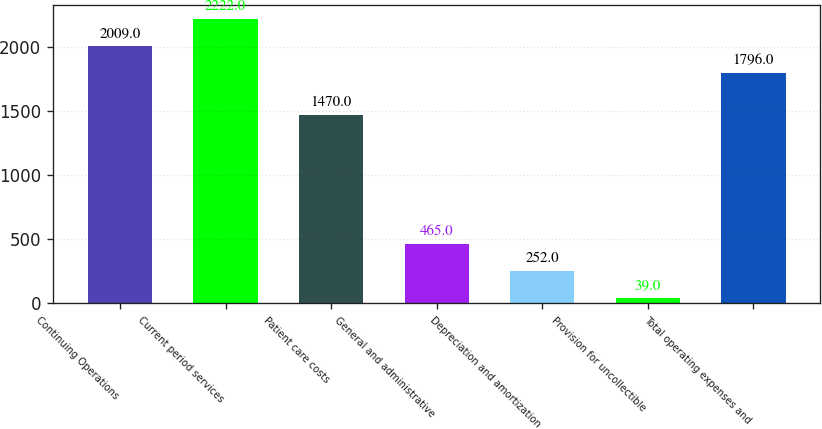<chart> <loc_0><loc_0><loc_500><loc_500><bar_chart><fcel>Continuing Operations<fcel>Current period services<fcel>Patient care costs<fcel>General and administrative<fcel>Depreciation and amortization<fcel>Provision for uncollectible<fcel>Total operating expenses and<nl><fcel>2009<fcel>2222<fcel>1470<fcel>465<fcel>252<fcel>39<fcel>1796<nl></chart> 